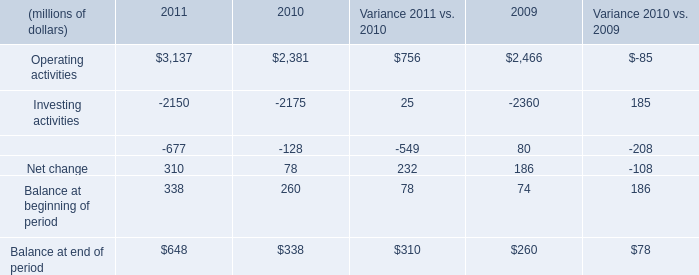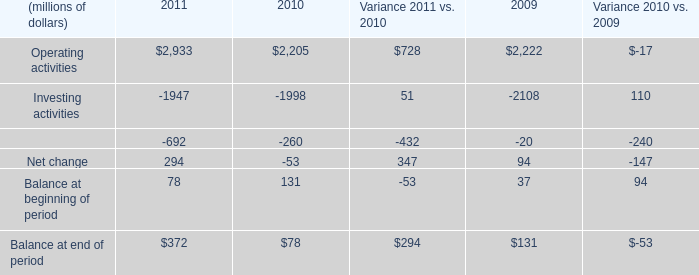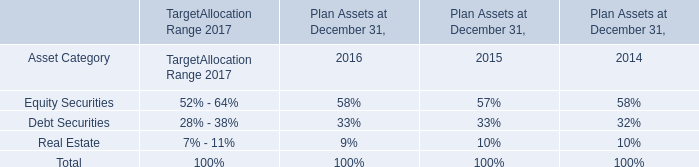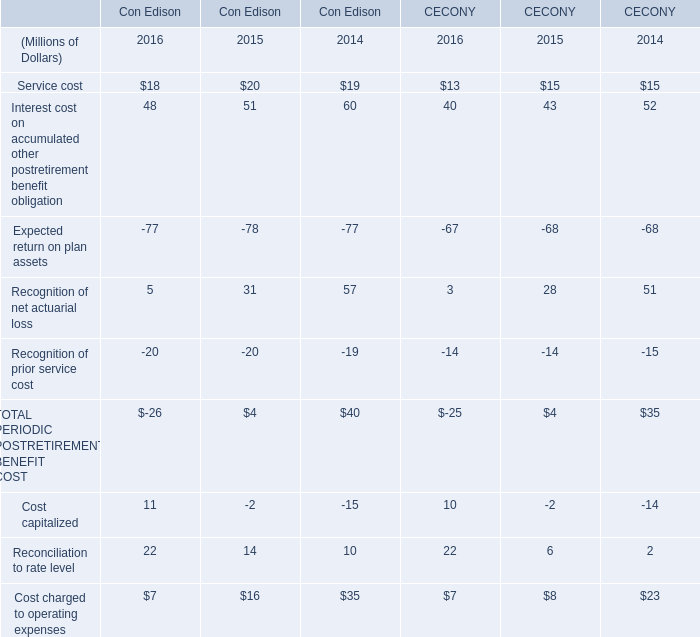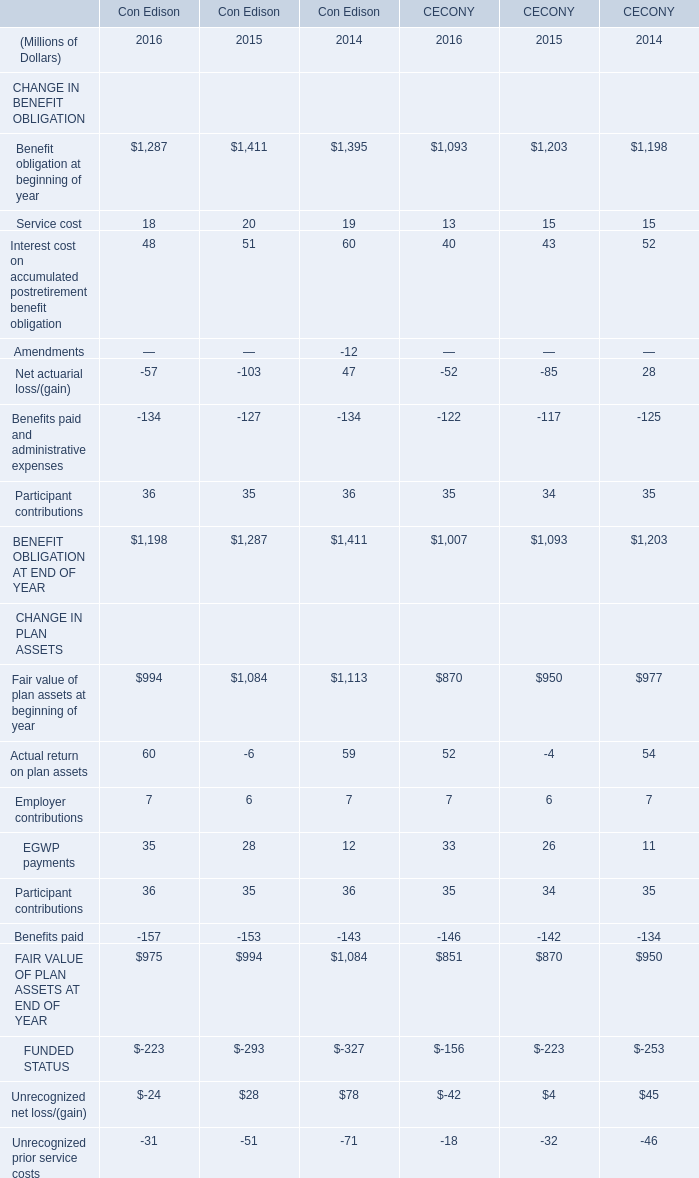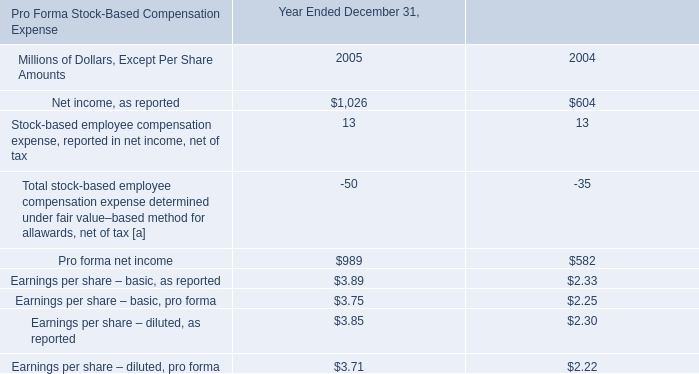what was the percentage difference of earnings per share 2013 basic pro forma compared to earnings per share 2013 diluted pro forma in 2004? 
Computations: ((2.25 - 2.22) / 2.25)
Answer: 0.01333. 